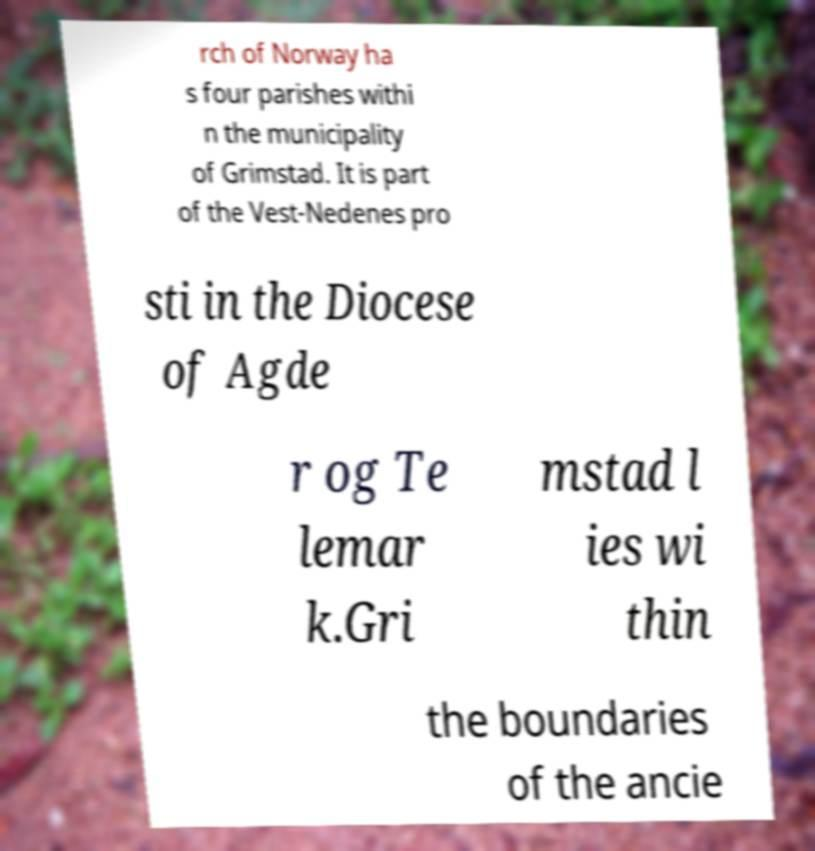Can you read and provide the text displayed in the image?This photo seems to have some interesting text. Can you extract and type it out for me? rch of Norway ha s four parishes withi n the municipality of Grimstad. It is part of the Vest-Nedenes pro sti in the Diocese of Agde r og Te lemar k.Gri mstad l ies wi thin the boundaries of the ancie 